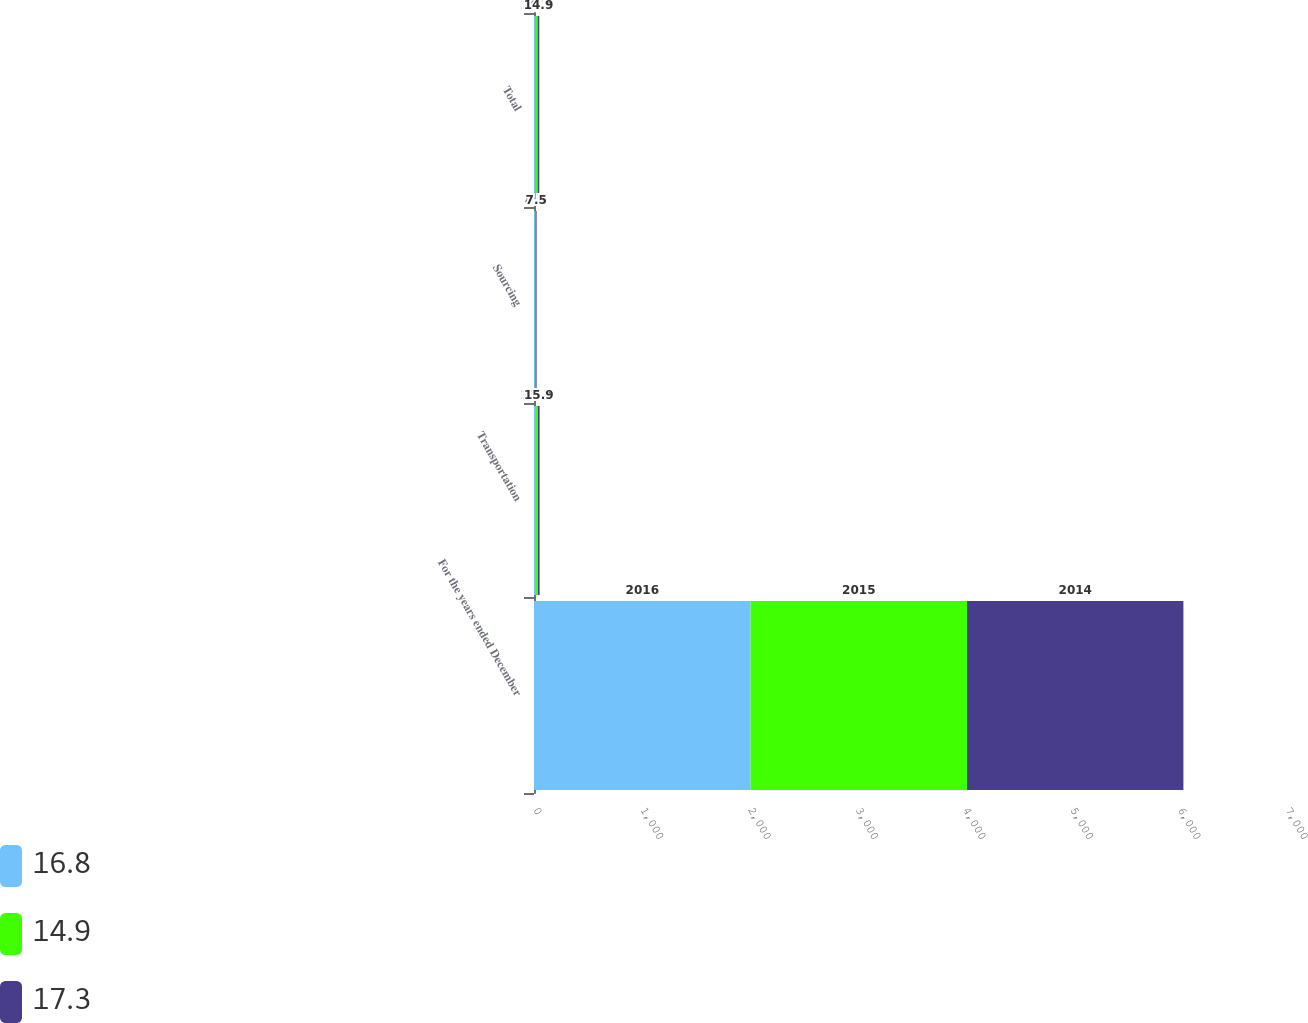<chart> <loc_0><loc_0><loc_500><loc_500><stacked_bar_chart><ecel><fcel>For the years ended December<fcel>Transportation<fcel>Sourcing<fcel>Total<nl><fcel>16.8<fcel>2016<fcel>18.4<fcel>8.5<fcel>17.3<nl><fcel>14.9<fcel>2015<fcel>17.9<fcel>8.1<fcel>16.8<nl><fcel>17.3<fcel>2014<fcel>15.9<fcel>7.5<fcel>14.9<nl></chart> 